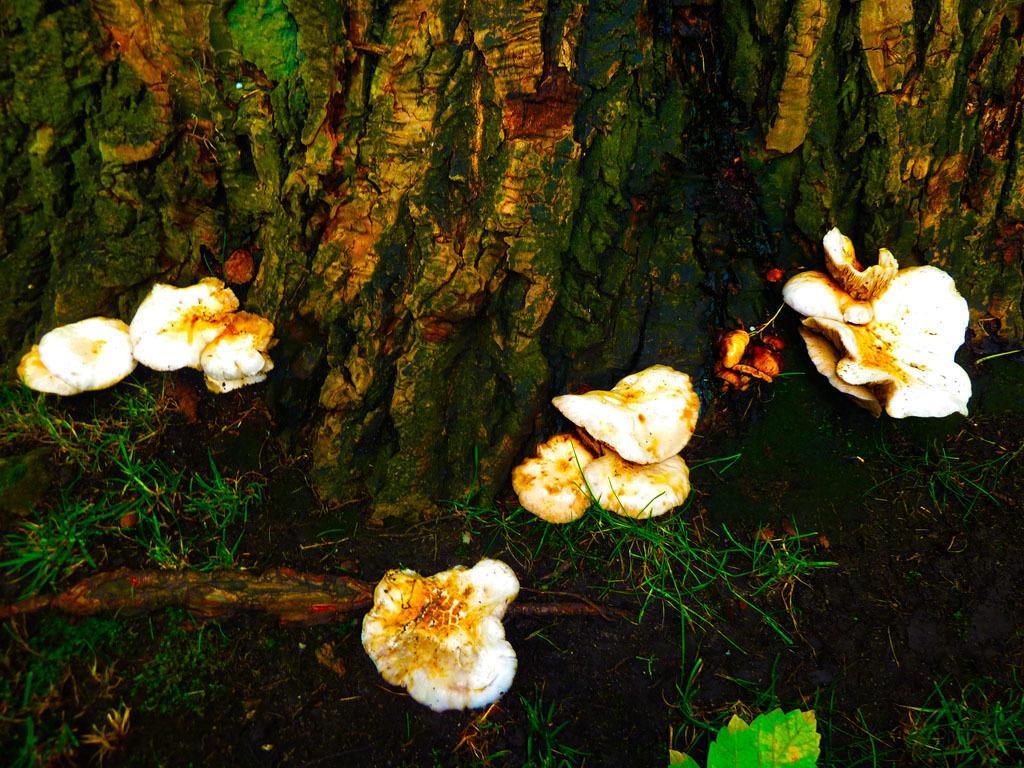Can you describe this image briefly? In this image we can see some mushrooms beside the bark of a tree. We can also see some grass. 